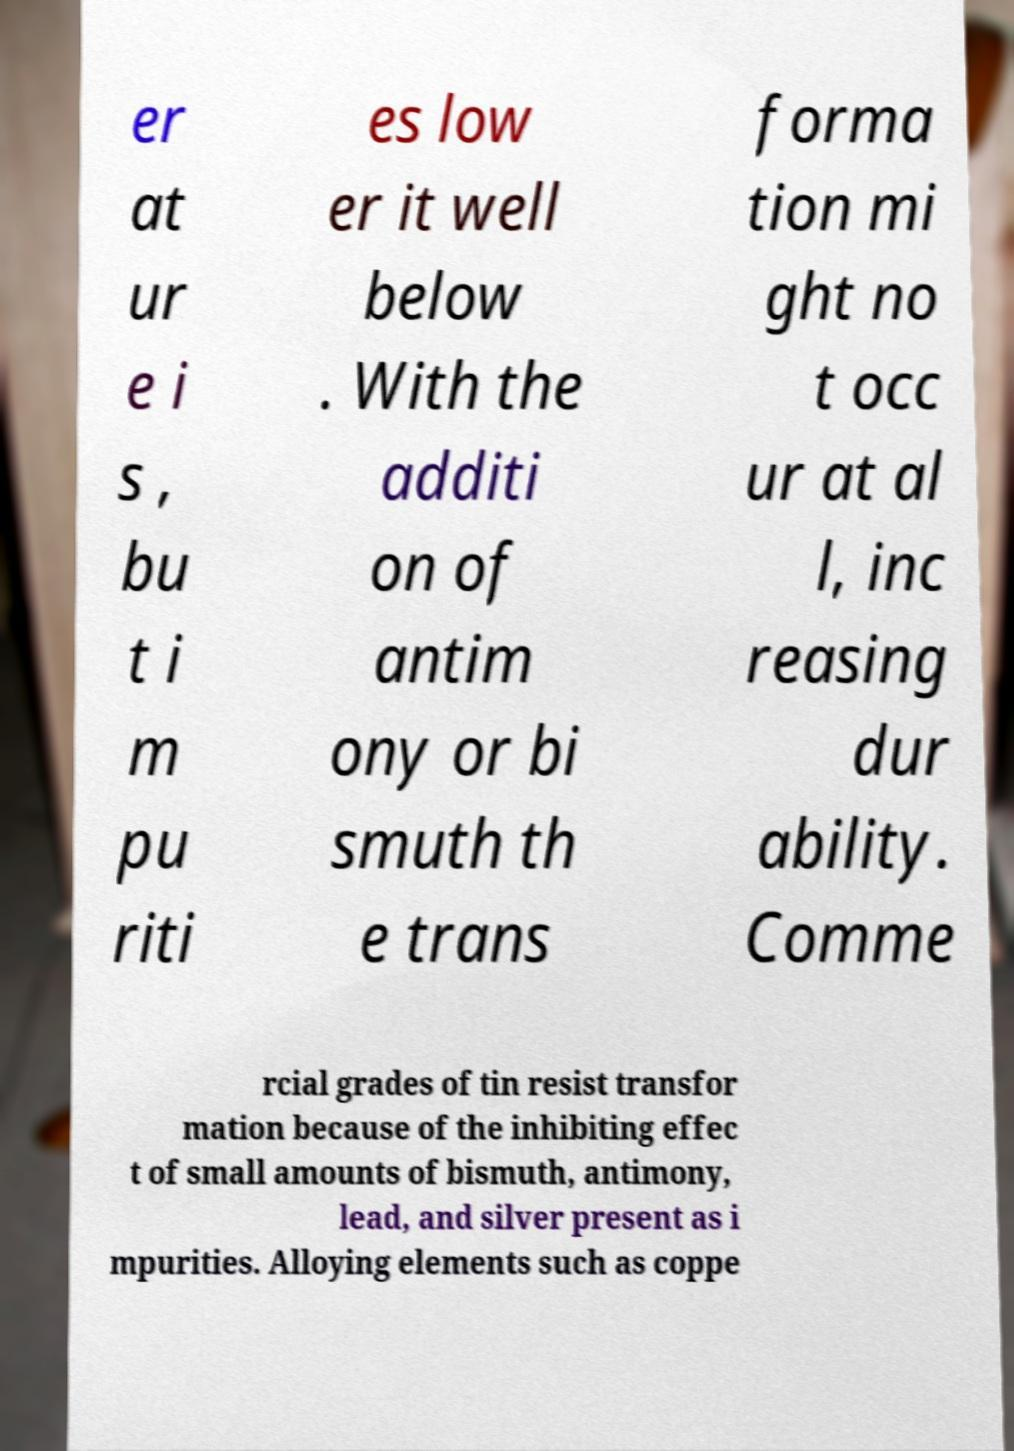For documentation purposes, I need the text within this image transcribed. Could you provide that? er at ur e i s , bu t i m pu riti es low er it well below . With the additi on of antim ony or bi smuth th e trans forma tion mi ght no t occ ur at al l, inc reasing dur ability. Comme rcial grades of tin resist transfor mation because of the inhibiting effec t of small amounts of bismuth, antimony, lead, and silver present as i mpurities. Alloying elements such as coppe 